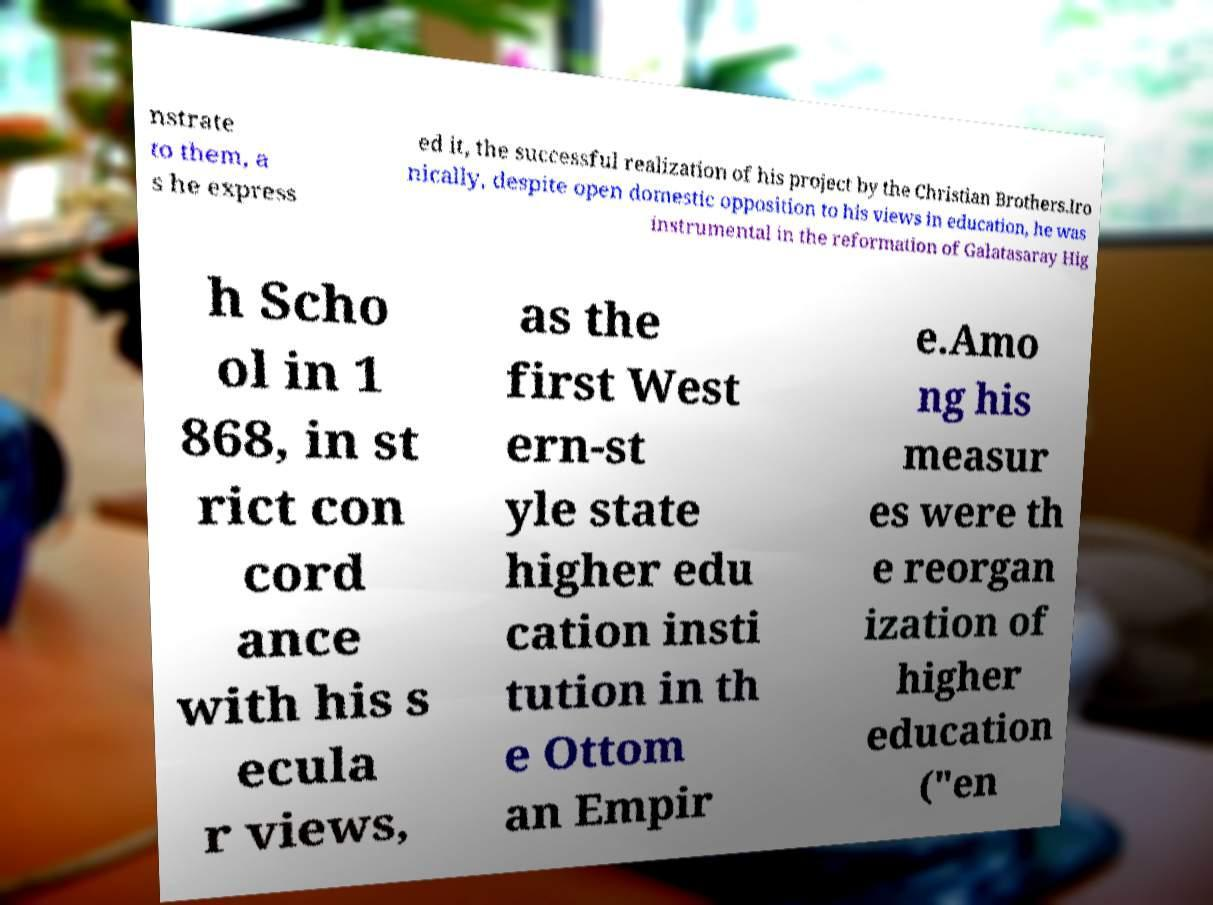Please read and relay the text visible in this image. What does it say? nstrate to them, a s he express ed it, the successful realization of his project by the Christian Brothers.Iro nically, despite open domestic opposition to his views in education, he was instrumental in the reformation of Galatasaray Hig h Scho ol in 1 868, in st rict con cord ance with his s ecula r views, as the first West ern-st yle state higher edu cation insti tution in th e Ottom an Empir e.Amo ng his measur es were th e reorgan ization of higher education ("en 